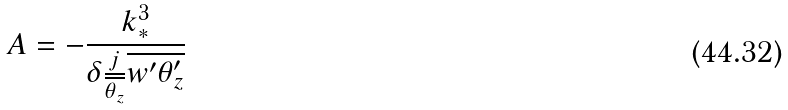<formula> <loc_0><loc_0><loc_500><loc_500>A = - \frac { k _ { * } ^ { 3 } } { \delta \frac { j } { \overline { \theta _ { z } } } \overline { w ^ { \prime } \theta _ { z } ^ { \prime } } }</formula> 